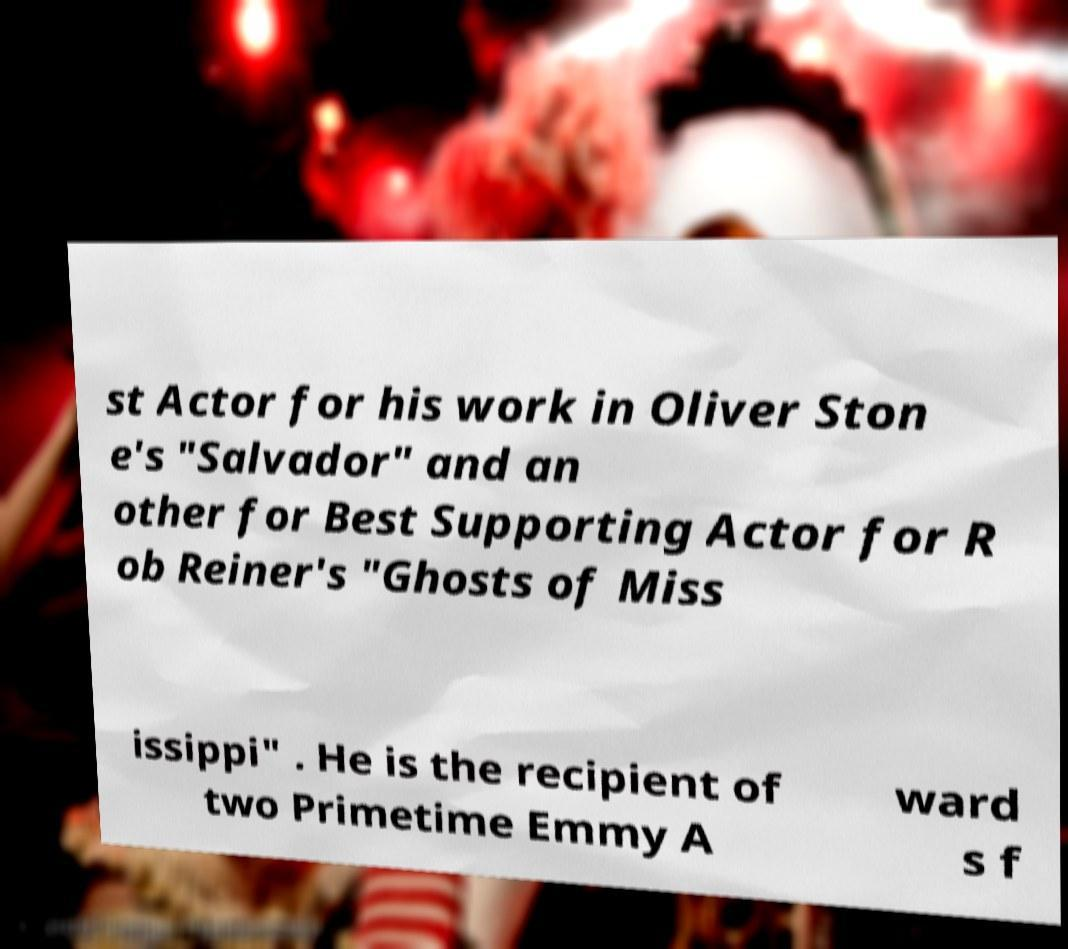Can you accurately transcribe the text from the provided image for me? st Actor for his work in Oliver Ston e's "Salvador" and an other for Best Supporting Actor for R ob Reiner's "Ghosts of Miss issippi" . He is the recipient of two Primetime Emmy A ward s f 